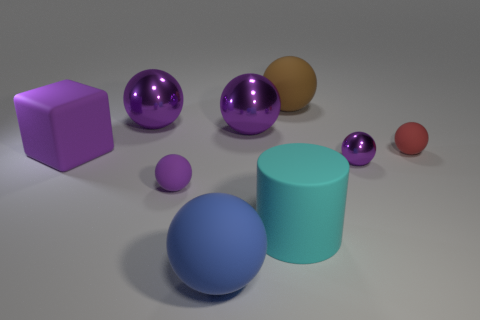What could be the purpose of arranging these objects in this way? The arrangement of these objects might serve several purposes. Aesthetically, it creates a visually pleasing composition with varying colors and shapes. Educationally, this could be used to teach concepts such as geometry, spatial relationships, and size comparison. In digital art or 3D modeling, such a scene could be used to demonstrate rendering techniques, lighting effects, and material textures. 